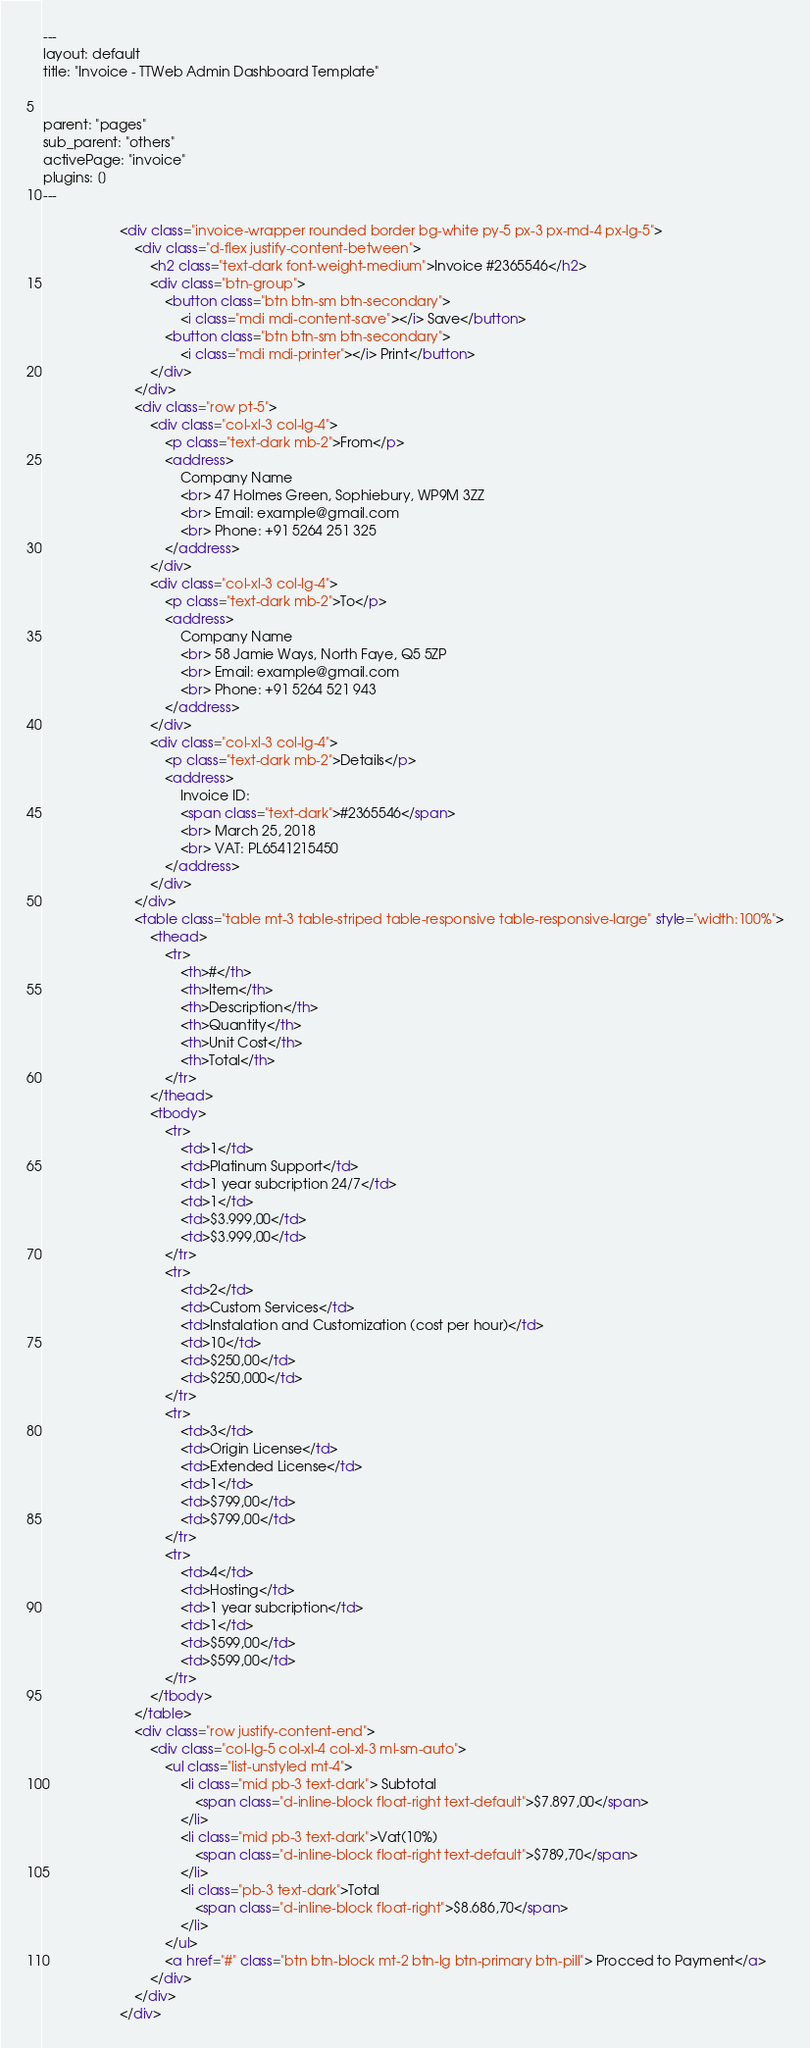<code> <loc_0><loc_0><loc_500><loc_500><_HTML_>---
layout: default
title: "Invoice - TTWeb Admin Dashboard Template"


parent: "pages"
sub_parent: "others"
activePage: "invoice"
plugins: []
---

					<div class="invoice-wrapper rounded border bg-white py-5 px-3 px-md-4 px-lg-5">
						<div class="d-flex justify-content-between">
							<h2 class="text-dark font-weight-medium">Invoice #2365546</h2>
							<div class="btn-group">
								<button class="btn btn-sm btn-secondary">
									<i class="mdi mdi-content-save"></i> Save</button>
								<button class="btn btn-sm btn-secondary">
									<i class="mdi mdi-printer"></i> Print</button>
							</div>
						</div>
						<div class="row pt-5">
							<div class="col-xl-3 col-lg-4">
								<p class="text-dark mb-2">From</p>
								<address>
									Company Name
									<br> 47 Holmes Green, Sophiebury, WP9M 3ZZ
									<br> Email: example@gmail.com
									<br> Phone: +91 5264 251 325
								</address>
							</div>
							<div class="col-xl-3 col-lg-4">
								<p class="text-dark mb-2">To</p>
								<address>
									Company Name
									<br> 58 Jamie Ways, North Faye, Q5 5ZP
									<br> Email: example@gmail.com
									<br> Phone: +91 5264 521 943
								</address>
							</div>
							<div class="col-xl-3 col-lg-4">
								<p class="text-dark mb-2">Details</p>
								<address>
									Invoice ID:
									<span class="text-dark">#2365546</span>
									<br> March 25, 2018
									<br> VAT: PL6541215450
								</address>
							</div>
						</div>
						<table class="table mt-3 table-striped table-responsive table-responsive-large" style="width:100%">
							<thead>
								<tr>
									<th>#</th>
									<th>Item</th>
									<th>Description</th>
									<th>Quantity</th>
									<th>Unit Cost</th>
									<th>Total</th>
								</tr>
							</thead>
							<tbody>
								<tr>
									<td>1</td>
									<td>Platinum Support</td>
									<td>1 year subcription 24/7</td>
									<td>1</td>
									<td>$3.999,00</td>
									<td>$3.999,00</td>
								</tr>
								<tr>
									<td>2</td>
									<td>Custom Services</td>
									<td>Instalation and Customization (cost per hour)</td>
									<td>10</td>
									<td>$250,00</td>
									<td>$250,000</td>
								</tr>
								<tr>
									<td>3</td>
									<td>Origin License</td>
									<td>Extended License</td>
									<td>1</td>
									<td>$799,00</td>
									<td>$799,00</td>
								</tr>
								<tr>
									<td>4</td>
									<td>Hosting</td>
									<td>1 year subcription</td>
									<td>1</td>
									<td>$599,00</td>
									<td>$599,00</td>
								</tr>
							</tbody>
						</table>
						<div class="row justify-content-end">
							<div class="col-lg-5 col-xl-4 col-xl-3 ml-sm-auto">
								<ul class="list-unstyled mt-4">
									<li class="mid pb-3 text-dark"> Subtotal
										<span class="d-inline-block float-right text-default">$7.897,00</span>
									</li>
									<li class="mid pb-3 text-dark">Vat(10%)
										<span class="d-inline-block float-right text-default">$789,70</span>
									</li>
									<li class="pb-3 text-dark">Total
										<span class="d-inline-block float-right">$8.686,70</span>
									</li>
								</ul>
								<a href="#" class="btn btn-block mt-2 btn-lg btn-primary btn-pill"> Procced to Payment</a>
							</div>
						</div>
					</div>
</code> 